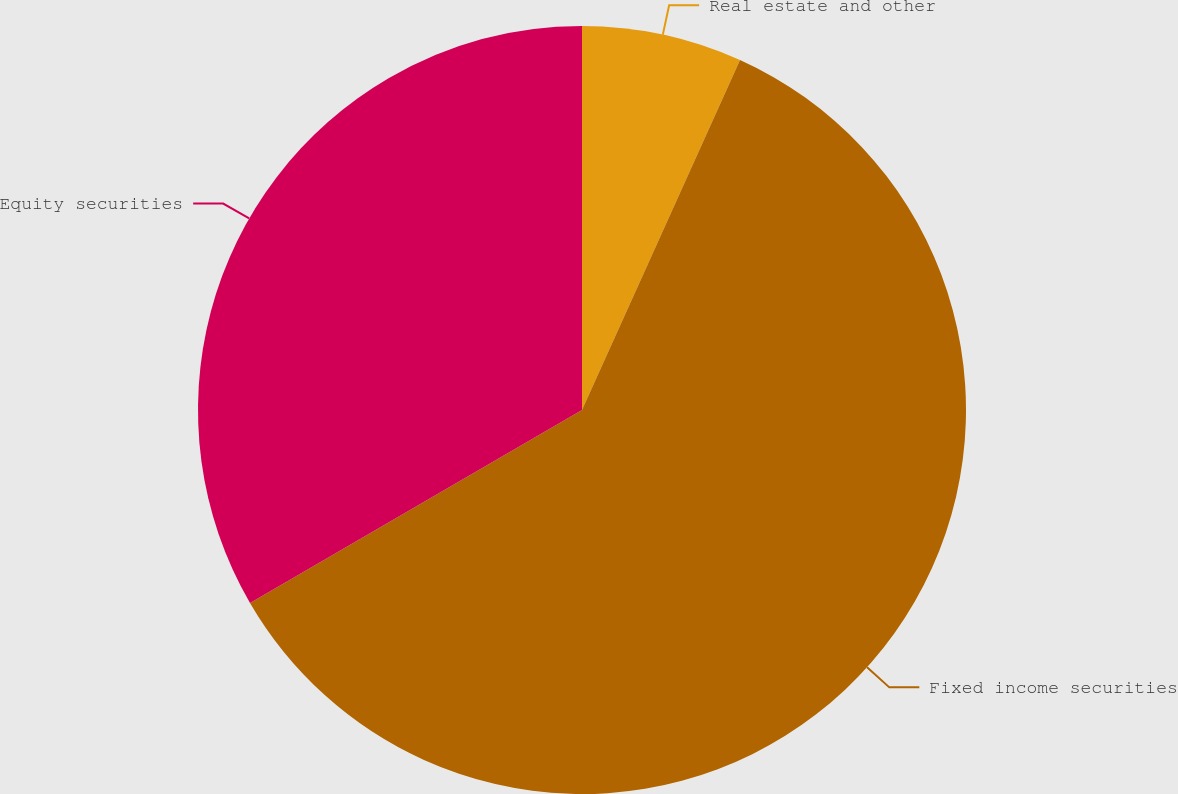Convert chart to OTSL. <chart><loc_0><loc_0><loc_500><loc_500><pie_chart><fcel>Real estate and other<fcel>Fixed income securities<fcel>Equity securities<nl><fcel>6.75%<fcel>59.87%<fcel>33.38%<nl></chart> 